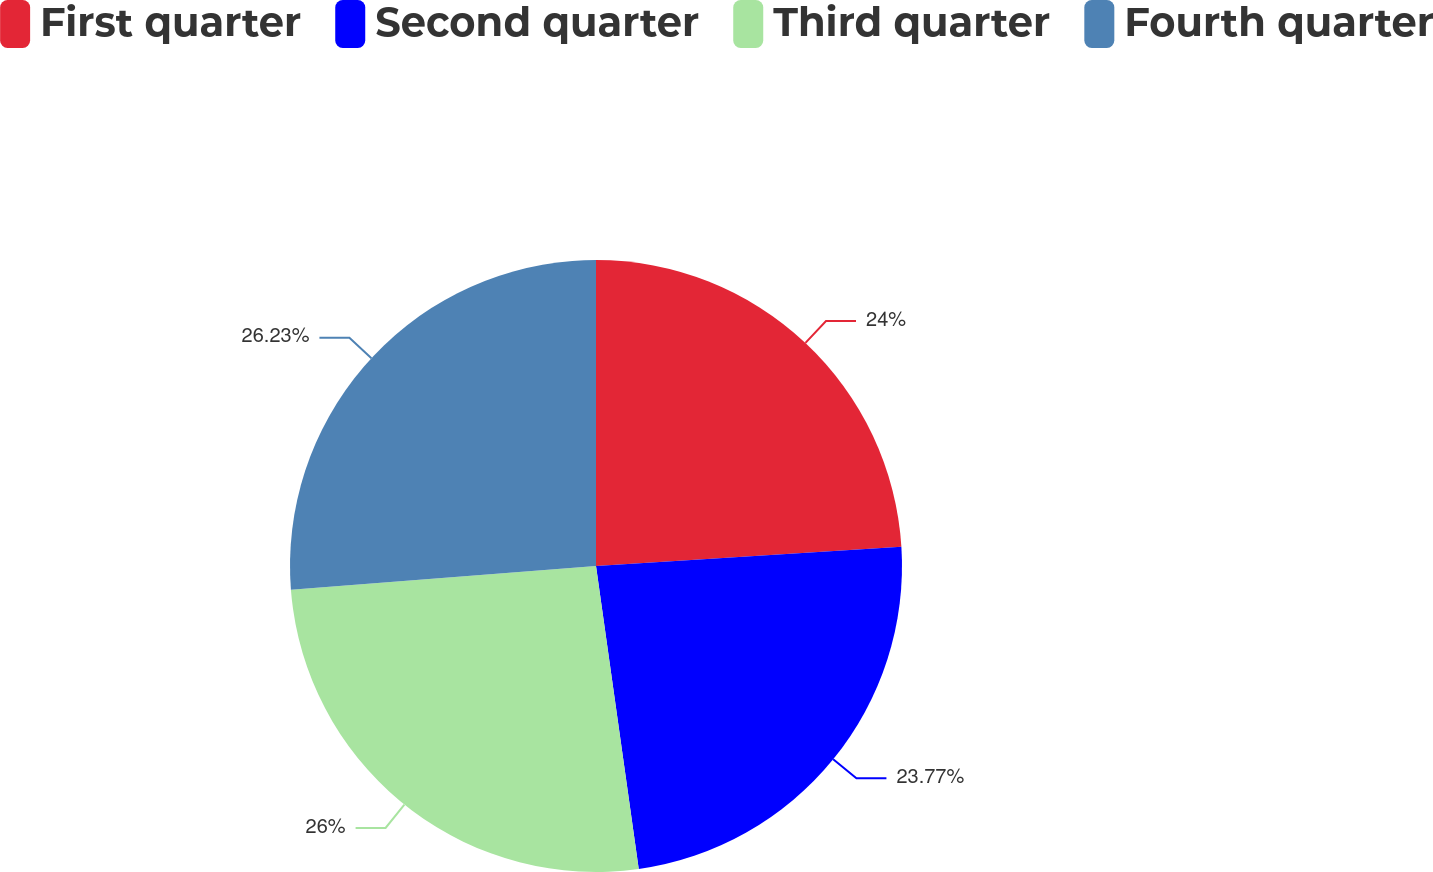Convert chart to OTSL. <chart><loc_0><loc_0><loc_500><loc_500><pie_chart><fcel>First quarter<fcel>Second quarter<fcel>Third quarter<fcel>Fourth quarter<nl><fcel>24.0%<fcel>23.77%<fcel>26.0%<fcel>26.23%<nl></chart> 